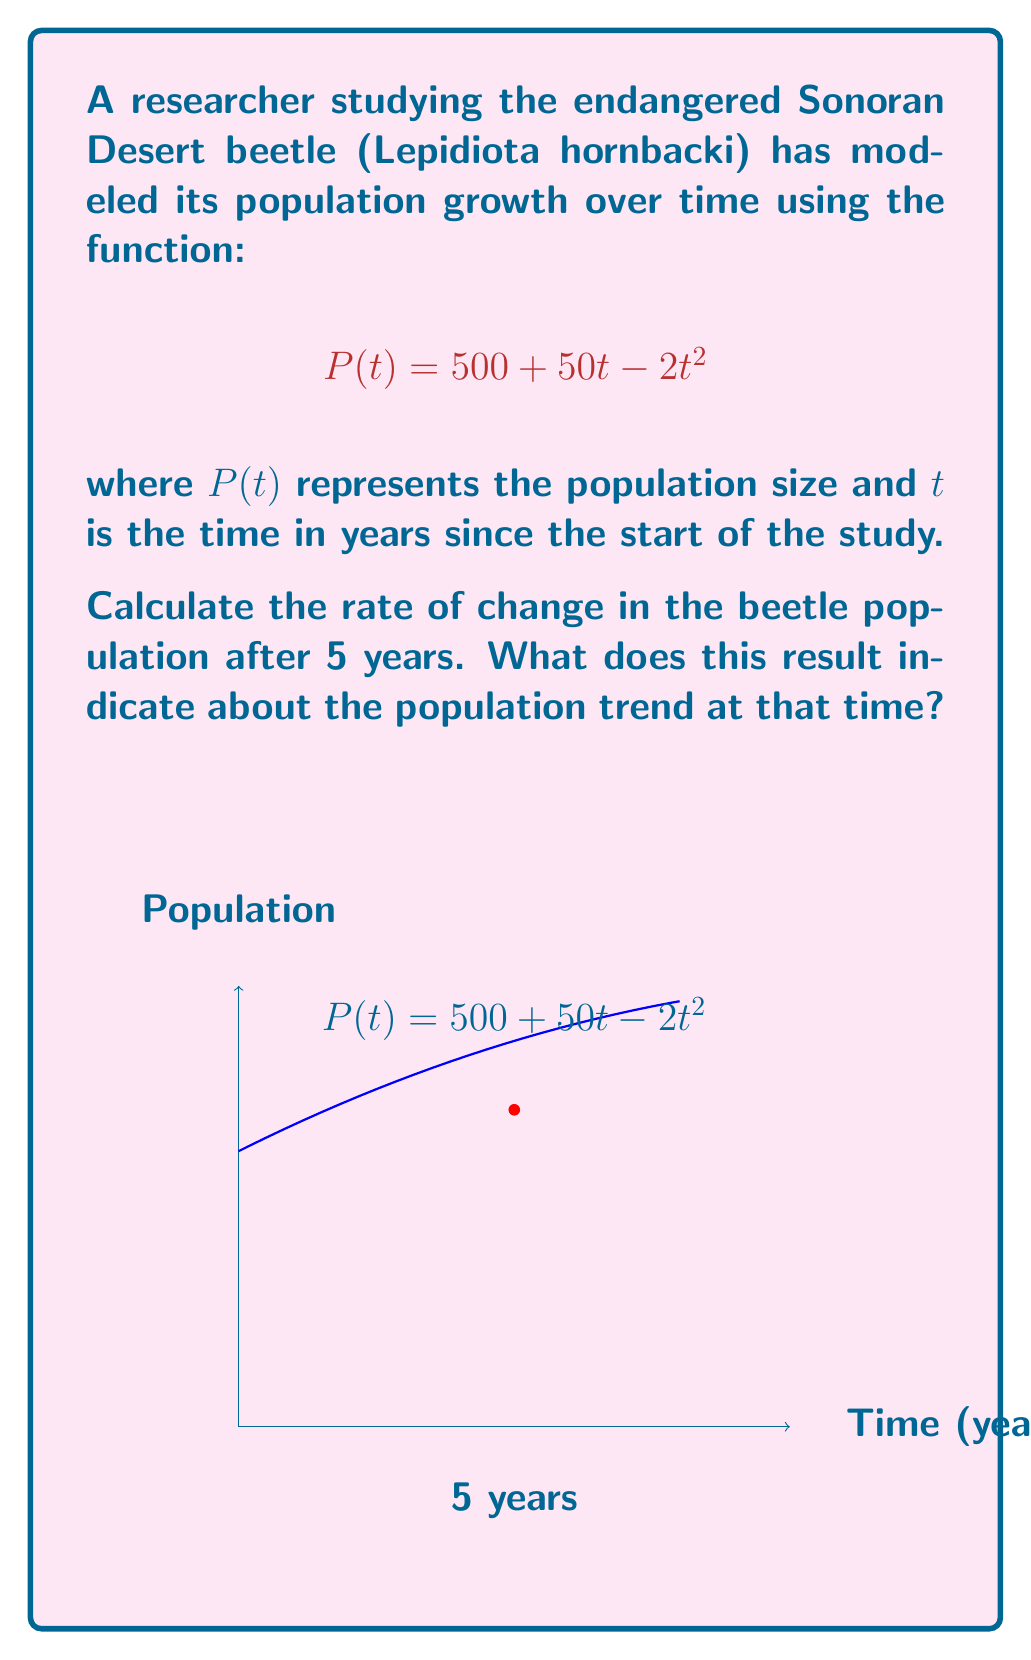Give your solution to this math problem. To solve this problem, we need to follow these steps:

1) The rate of change in population is given by the derivative of $P(t)$ with respect to $t$.

2) Let's find $P'(t)$:
   $$P(t) = 500 + 50t - 2t^2$$
   $$P'(t) = 50 - 4t$$

3) Now, we need to evaluate $P'(t)$ at $t = 5$:
   $$P'(5) = 50 - 4(5) = 50 - 20 = 30$$

4) Interpretation:
   - The positive value of 30 indicates that the population is still growing after 5 years.
   - However, since the original function is quadratic with a negative coefficient for $t^2$, the rate of growth is decreasing over time.
   - The population will reach its maximum when $P'(t) = 0$, which occurs at $t = 12.5$ years.

5) In the context of beetle research:
   - This model suggests that the Sonoran Desert beetle population is increasing at a rate of 30 beetles per year at the 5-year mark.
   - The researcher should be aware that this growth rate is slowing down and will eventually become negative, indicating a future decline in population.
Answer: 30 beetles/year; population still growing but at a decreasing rate 